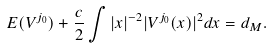<formula> <loc_0><loc_0><loc_500><loc_500>E ( V ^ { j _ { 0 } } ) + \frac { c } { 2 } \int | x | ^ { - 2 } | V ^ { j _ { 0 } } ( x ) | ^ { 2 } d x = d _ { M } .</formula> 